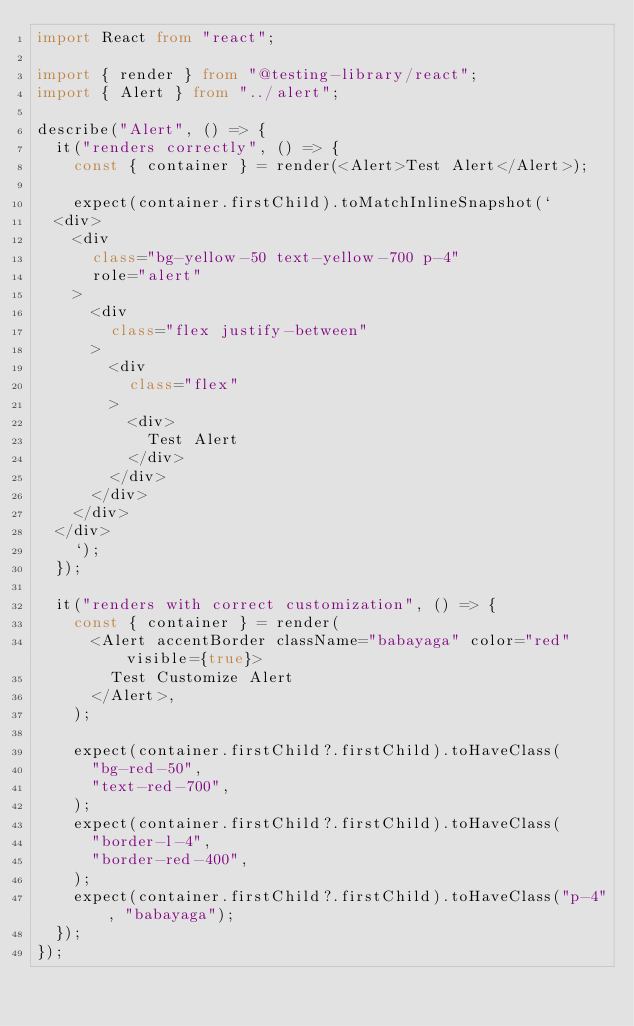Convert code to text. <code><loc_0><loc_0><loc_500><loc_500><_TypeScript_>import React from "react";

import { render } from "@testing-library/react";
import { Alert } from "../alert";

describe("Alert", () => {
  it("renders correctly", () => {
    const { container } = render(<Alert>Test Alert</Alert>);

    expect(container.firstChild).toMatchInlineSnapshot(`
  <div>
    <div
      class="bg-yellow-50 text-yellow-700 p-4"
      role="alert"
    >
      <div
        class="flex justify-between"
      >
        <div
          class="flex"
        >
          <div>
            Test Alert
          </div>
        </div>
      </div>
    </div>
  </div>
    `);
  });

  it("renders with correct customization", () => {
    const { container } = render(
      <Alert accentBorder className="babayaga" color="red" visible={true}>
        Test Customize Alert
      </Alert>,
    );

    expect(container.firstChild?.firstChild).toHaveClass(
      "bg-red-50",
      "text-red-700",
    );
    expect(container.firstChild?.firstChild).toHaveClass(
      "border-l-4",
      "border-red-400",
    );
    expect(container.firstChild?.firstChild).toHaveClass("p-4", "babayaga");
  });
});
</code> 